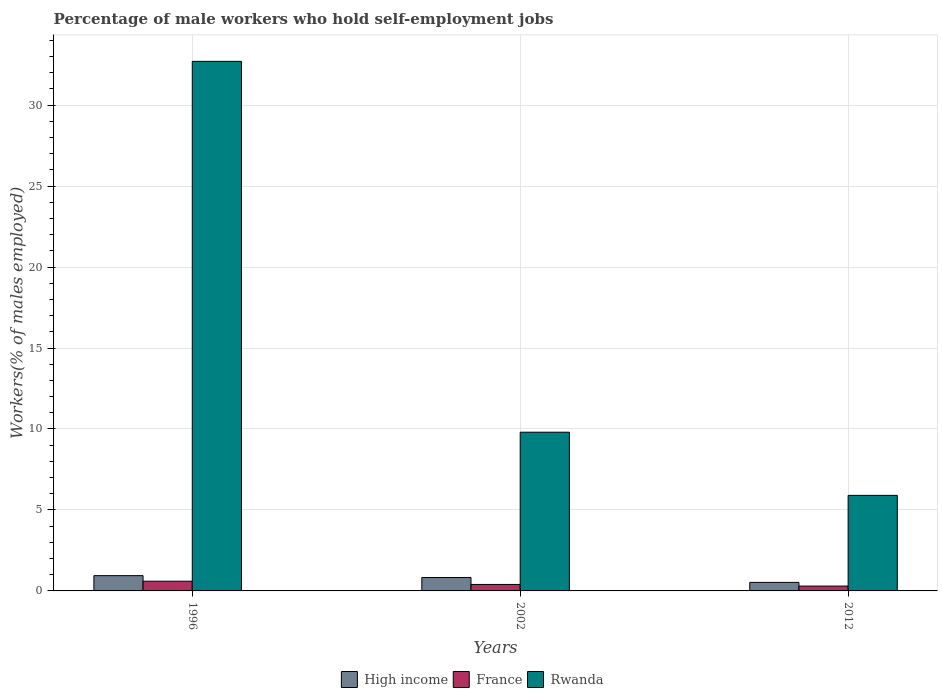How many different coloured bars are there?
Offer a very short reply. 3. How many groups of bars are there?
Ensure brevity in your answer.  3. Are the number of bars per tick equal to the number of legend labels?
Make the answer very short. Yes. How many bars are there on the 2nd tick from the right?
Your answer should be very brief. 3. What is the label of the 2nd group of bars from the left?
Your answer should be very brief. 2002. What is the percentage of self-employed male workers in High income in 2012?
Give a very brief answer. 0.53. Across all years, what is the maximum percentage of self-employed male workers in France?
Offer a very short reply. 0.6. Across all years, what is the minimum percentage of self-employed male workers in Rwanda?
Your response must be concise. 5.9. In which year was the percentage of self-employed male workers in France minimum?
Keep it short and to the point. 2012. What is the total percentage of self-employed male workers in France in the graph?
Your answer should be compact. 1.3. What is the difference between the percentage of self-employed male workers in Rwanda in 1996 and that in 2002?
Your answer should be compact. 22.9. What is the difference between the percentage of self-employed male workers in High income in 2002 and the percentage of self-employed male workers in France in 1996?
Your response must be concise. 0.23. What is the average percentage of self-employed male workers in Rwanda per year?
Give a very brief answer. 16.13. In the year 2002, what is the difference between the percentage of self-employed male workers in Rwanda and percentage of self-employed male workers in High income?
Provide a succinct answer. 8.97. What is the ratio of the percentage of self-employed male workers in Rwanda in 2002 to that in 2012?
Your answer should be very brief. 1.66. Is the percentage of self-employed male workers in Rwanda in 1996 less than that in 2002?
Your response must be concise. No. Is the difference between the percentage of self-employed male workers in Rwanda in 1996 and 2002 greater than the difference between the percentage of self-employed male workers in High income in 1996 and 2002?
Offer a very short reply. Yes. What is the difference between the highest and the second highest percentage of self-employed male workers in Rwanda?
Keep it short and to the point. 22.9. What is the difference between the highest and the lowest percentage of self-employed male workers in High income?
Your answer should be very brief. 0.42. In how many years, is the percentage of self-employed male workers in Rwanda greater than the average percentage of self-employed male workers in Rwanda taken over all years?
Keep it short and to the point. 1. What does the 2nd bar from the left in 2012 represents?
Offer a terse response. France. What does the 2nd bar from the right in 2012 represents?
Your response must be concise. France. Is it the case that in every year, the sum of the percentage of self-employed male workers in High income and percentage of self-employed male workers in France is greater than the percentage of self-employed male workers in Rwanda?
Provide a succinct answer. No. Are all the bars in the graph horizontal?
Your answer should be very brief. No. What is the title of the graph?
Keep it short and to the point. Percentage of male workers who hold self-employment jobs. Does "Ethiopia" appear as one of the legend labels in the graph?
Keep it short and to the point. No. What is the label or title of the X-axis?
Provide a succinct answer. Years. What is the label or title of the Y-axis?
Offer a very short reply. Workers(% of males employed). What is the Workers(% of males employed) in High income in 1996?
Your answer should be compact. 0.94. What is the Workers(% of males employed) of France in 1996?
Your answer should be compact. 0.6. What is the Workers(% of males employed) of Rwanda in 1996?
Ensure brevity in your answer.  32.7. What is the Workers(% of males employed) in High income in 2002?
Your answer should be very brief. 0.83. What is the Workers(% of males employed) of France in 2002?
Ensure brevity in your answer.  0.4. What is the Workers(% of males employed) in Rwanda in 2002?
Your answer should be compact. 9.8. What is the Workers(% of males employed) of High income in 2012?
Offer a very short reply. 0.53. What is the Workers(% of males employed) in France in 2012?
Provide a succinct answer. 0.3. What is the Workers(% of males employed) in Rwanda in 2012?
Your response must be concise. 5.9. Across all years, what is the maximum Workers(% of males employed) of High income?
Provide a short and direct response. 0.94. Across all years, what is the maximum Workers(% of males employed) in France?
Your response must be concise. 0.6. Across all years, what is the maximum Workers(% of males employed) in Rwanda?
Give a very brief answer. 32.7. Across all years, what is the minimum Workers(% of males employed) in High income?
Give a very brief answer. 0.53. Across all years, what is the minimum Workers(% of males employed) in France?
Give a very brief answer. 0.3. Across all years, what is the minimum Workers(% of males employed) in Rwanda?
Provide a short and direct response. 5.9. What is the total Workers(% of males employed) in High income in the graph?
Provide a short and direct response. 2.3. What is the total Workers(% of males employed) of France in the graph?
Your answer should be very brief. 1.3. What is the total Workers(% of males employed) of Rwanda in the graph?
Offer a terse response. 48.4. What is the difference between the Workers(% of males employed) of High income in 1996 and that in 2002?
Your response must be concise. 0.12. What is the difference between the Workers(% of males employed) in France in 1996 and that in 2002?
Your answer should be compact. 0.2. What is the difference between the Workers(% of males employed) of Rwanda in 1996 and that in 2002?
Give a very brief answer. 22.9. What is the difference between the Workers(% of males employed) of High income in 1996 and that in 2012?
Your answer should be very brief. 0.42. What is the difference between the Workers(% of males employed) of France in 1996 and that in 2012?
Your answer should be very brief. 0.3. What is the difference between the Workers(% of males employed) in Rwanda in 1996 and that in 2012?
Offer a terse response. 26.8. What is the difference between the Workers(% of males employed) in High income in 2002 and that in 2012?
Ensure brevity in your answer.  0.3. What is the difference between the Workers(% of males employed) of Rwanda in 2002 and that in 2012?
Offer a terse response. 3.9. What is the difference between the Workers(% of males employed) of High income in 1996 and the Workers(% of males employed) of France in 2002?
Give a very brief answer. 0.54. What is the difference between the Workers(% of males employed) in High income in 1996 and the Workers(% of males employed) in Rwanda in 2002?
Provide a short and direct response. -8.86. What is the difference between the Workers(% of males employed) in France in 1996 and the Workers(% of males employed) in Rwanda in 2002?
Offer a very short reply. -9.2. What is the difference between the Workers(% of males employed) of High income in 1996 and the Workers(% of males employed) of France in 2012?
Give a very brief answer. 0.64. What is the difference between the Workers(% of males employed) in High income in 1996 and the Workers(% of males employed) in Rwanda in 2012?
Provide a short and direct response. -4.96. What is the difference between the Workers(% of males employed) of High income in 2002 and the Workers(% of males employed) of France in 2012?
Your answer should be very brief. 0.53. What is the difference between the Workers(% of males employed) in High income in 2002 and the Workers(% of males employed) in Rwanda in 2012?
Give a very brief answer. -5.07. What is the average Workers(% of males employed) of High income per year?
Keep it short and to the point. 0.77. What is the average Workers(% of males employed) in France per year?
Provide a short and direct response. 0.43. What is the average Workers(% of males employed) of Rwanda per year?
Provide a short and direct response. 16.13. In the year 1996, what is the difference between the Workers(% of males employed) in High income and Workers(% of males employed) in France?
Provide a short and direct response. 0.34. In the year 1996, what is the difference between the Workers(% of males employed) of High income and Workers(% of males employed) of Rwanda?
Offer a very short reply. -31.76. In the year 1996, what is the difference between the Workers(% of males employed) in France and Workers(% of males employed) in Rwanda?
Your answer should be very brief. -32.1. In the year 2002, what is the difference between the Workers(% of males employed) in High income and Workers(% of males employed) in France?
Provide a succinct answer. 0.43. In the year 2002, what is the difference between the Workers(% of males employed) of High income and Workers(% of males employed) of Rwanda?
Offer a terse response. -8.97. In the year 2012, what is the difference between the Workers(% of males employed) in High income and Workers(% of males employed) in France?
Provide a succinct answer. 0.23. In the year 2012, what is the difference between the Workers(% of males employed) of High income and Workers(% of males employed) of Rwanda?
Offer a very short reply. -5.37. What is the ratio of the Workers(% of males employed) in High income in 1996 to that in 2002?
Make the answer very short. 1.14. What is the ratio of the Workers(% of males employed) in France in 1996 to that in 2002?
Provide a short and direct response. 1.5. What is the ratio of the Workers(% of males employed) of Rwanda in 1996 to that in 2002?
Offer a very short reply. 3.34. What is the ratio of the Workers(% of males employed) of High income in 1996 to that in 2012?
Provide a succinct answer. 1.79. What is the ratio of the Workers(% of males employed) in Rwanda in 1996 to that in 2012?
Provide a succinct answer. 5.54. What is the ratio of the Workers(% of males employed) of High income in 2002 to that in 2012?
Provide a succinct answer. 1.57. What is the ratio of the Workers(% of males employed) in Rwanda in 2002 to that in 2012?
Offer a terse response. 1.66. What is the difference between the highest and the second highest Workers(% of males employed) in High income?
Offer a terse response. 0.12. What is the difference between the highest and the second highest Workers(% of males employed) in France?
Make the answer very short. 0.2. What is the difference between the highest and the second highest Workers(% of males employed) of Rwanda?
Give a very brief answer. 22.9. What is the difference between the highest and the lowest Workers(% of males employed) in High income?
Make the answer very short. 0.42. What is the difference between the highest and the lowest Workers(% of males employed) in France?
Offer a terse response. 0.3. What is the difference between the highest and the lowest Workers(% of males employed) of Rwanda?
Ensure brevity in your answer.  26.8. 